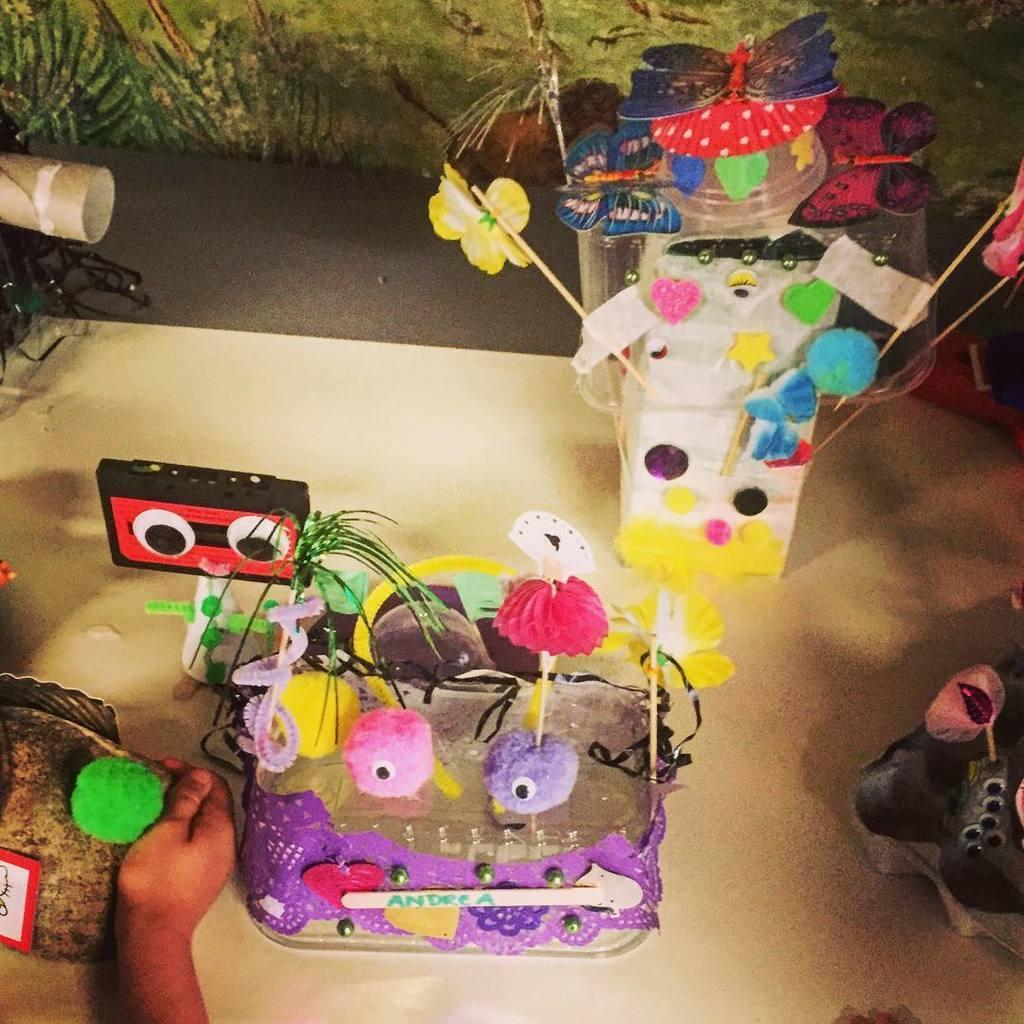Could you give a brief overview of what you see in this image? In this picture I can see toys on the surface. I can see the hand of a person on the left side. 